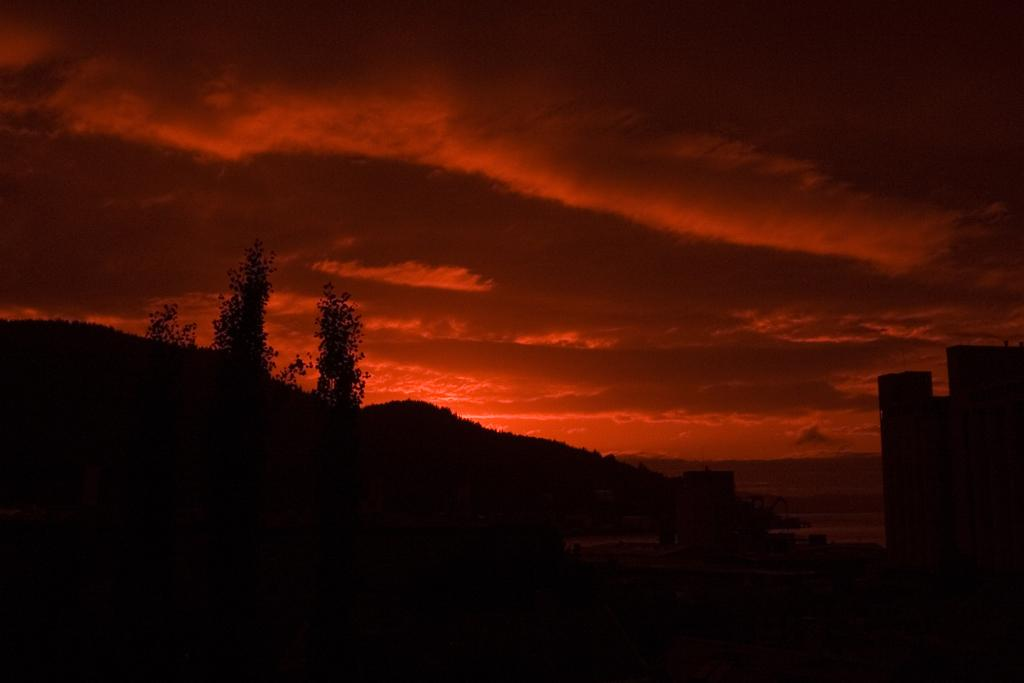What type of vegetation is visible in the front of the image? There are trees in the front of the image. What type of natural feature can be seen in the background of the image? There are mountains in the background of the image. What is the weather like in the image? The sky is cloudy in the image. What color is the sky in the image? The sky has a reddish color in the image. Is there an umbrella being used by anyone in the image? There is no umbrella present in the image. What type of wood is used to construct the trees in the image? The image does not provide information about the type of wood used to construct the trees. 